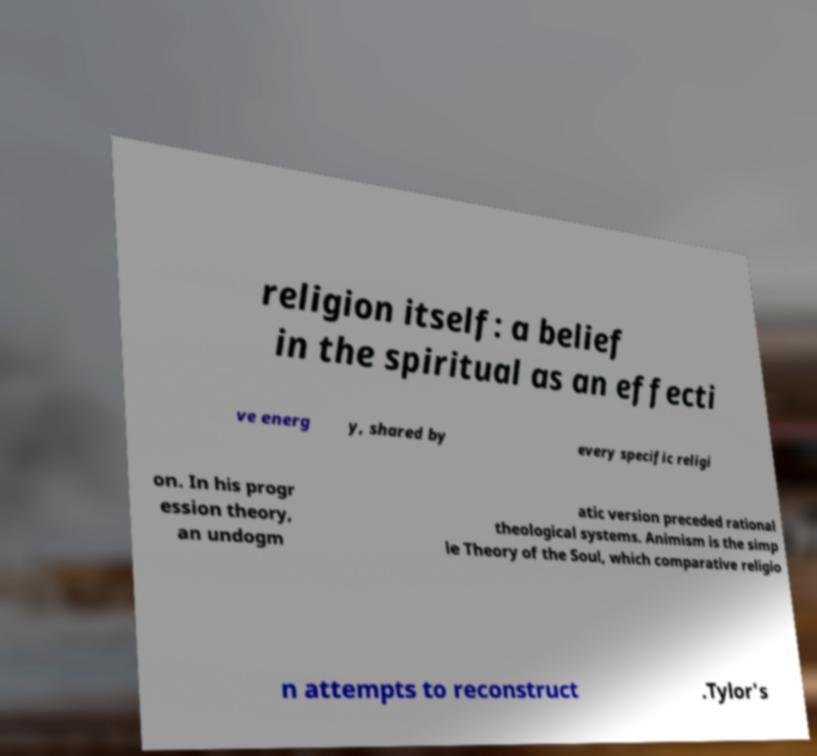Could you extract and type out the text from this image? religion itself: a belief in the spiritual as an effecti ve energ y, shared by every specific religi on. In his progr ession theory, an undogm atic version preceded rational theological systems. Animism is the simp le Theory of the Soul, which comparative religio n attempts to reconstruct .Tylor's 